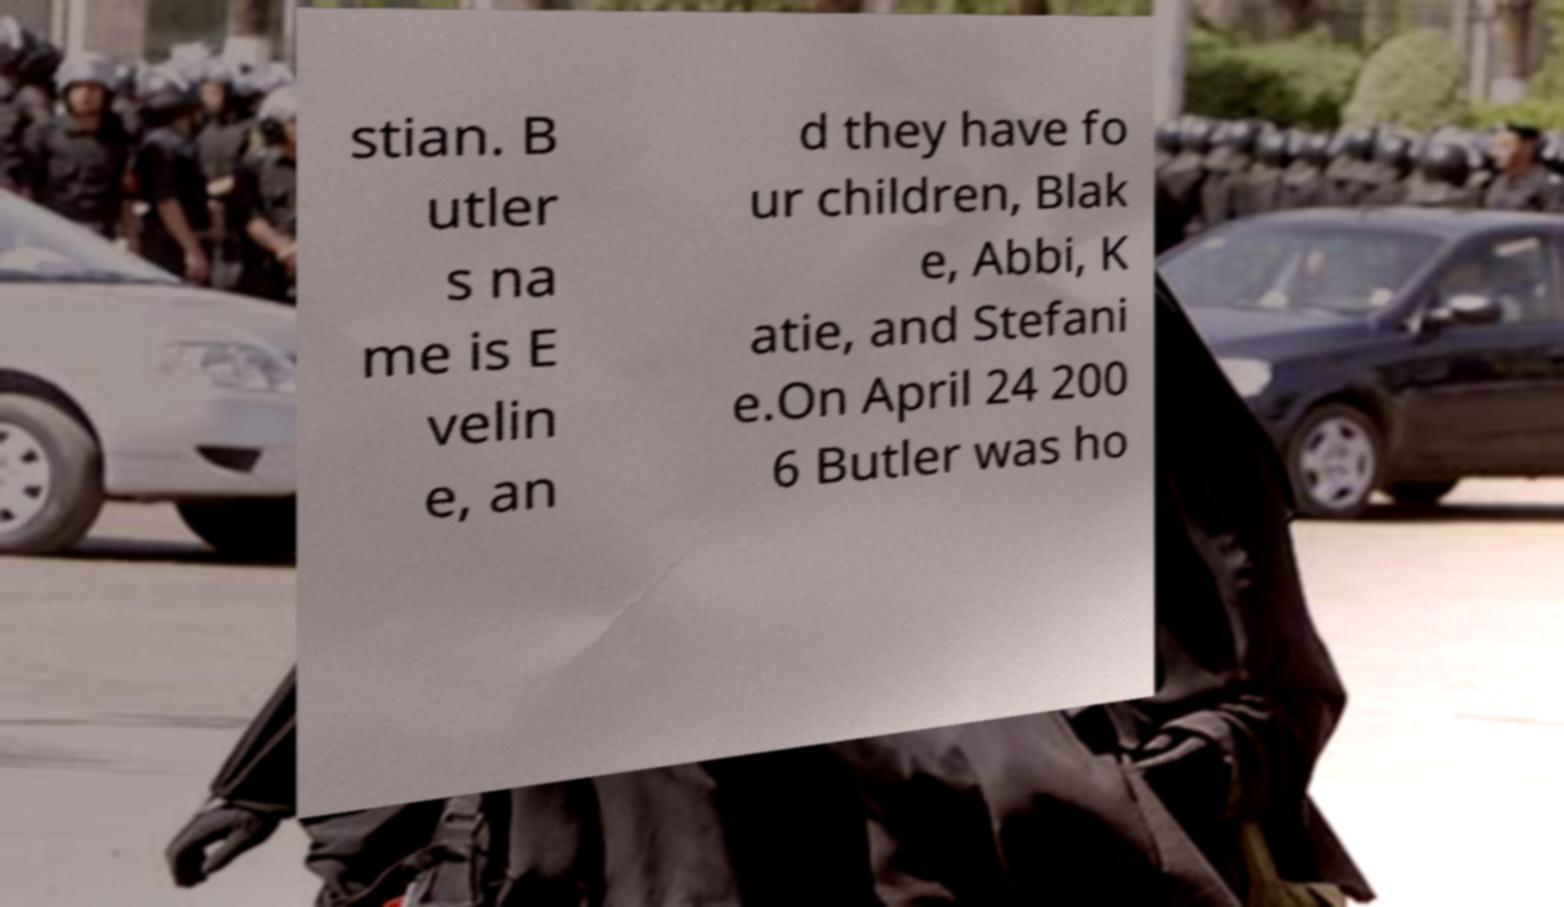I need the written content from this picture converted into text. Can you do that? stian. B utler s na me is E velin e, an d they have fo ur children, Blak e, Abbi, K atie, and Stefani e.On April 24 200 6 Butler was ho 